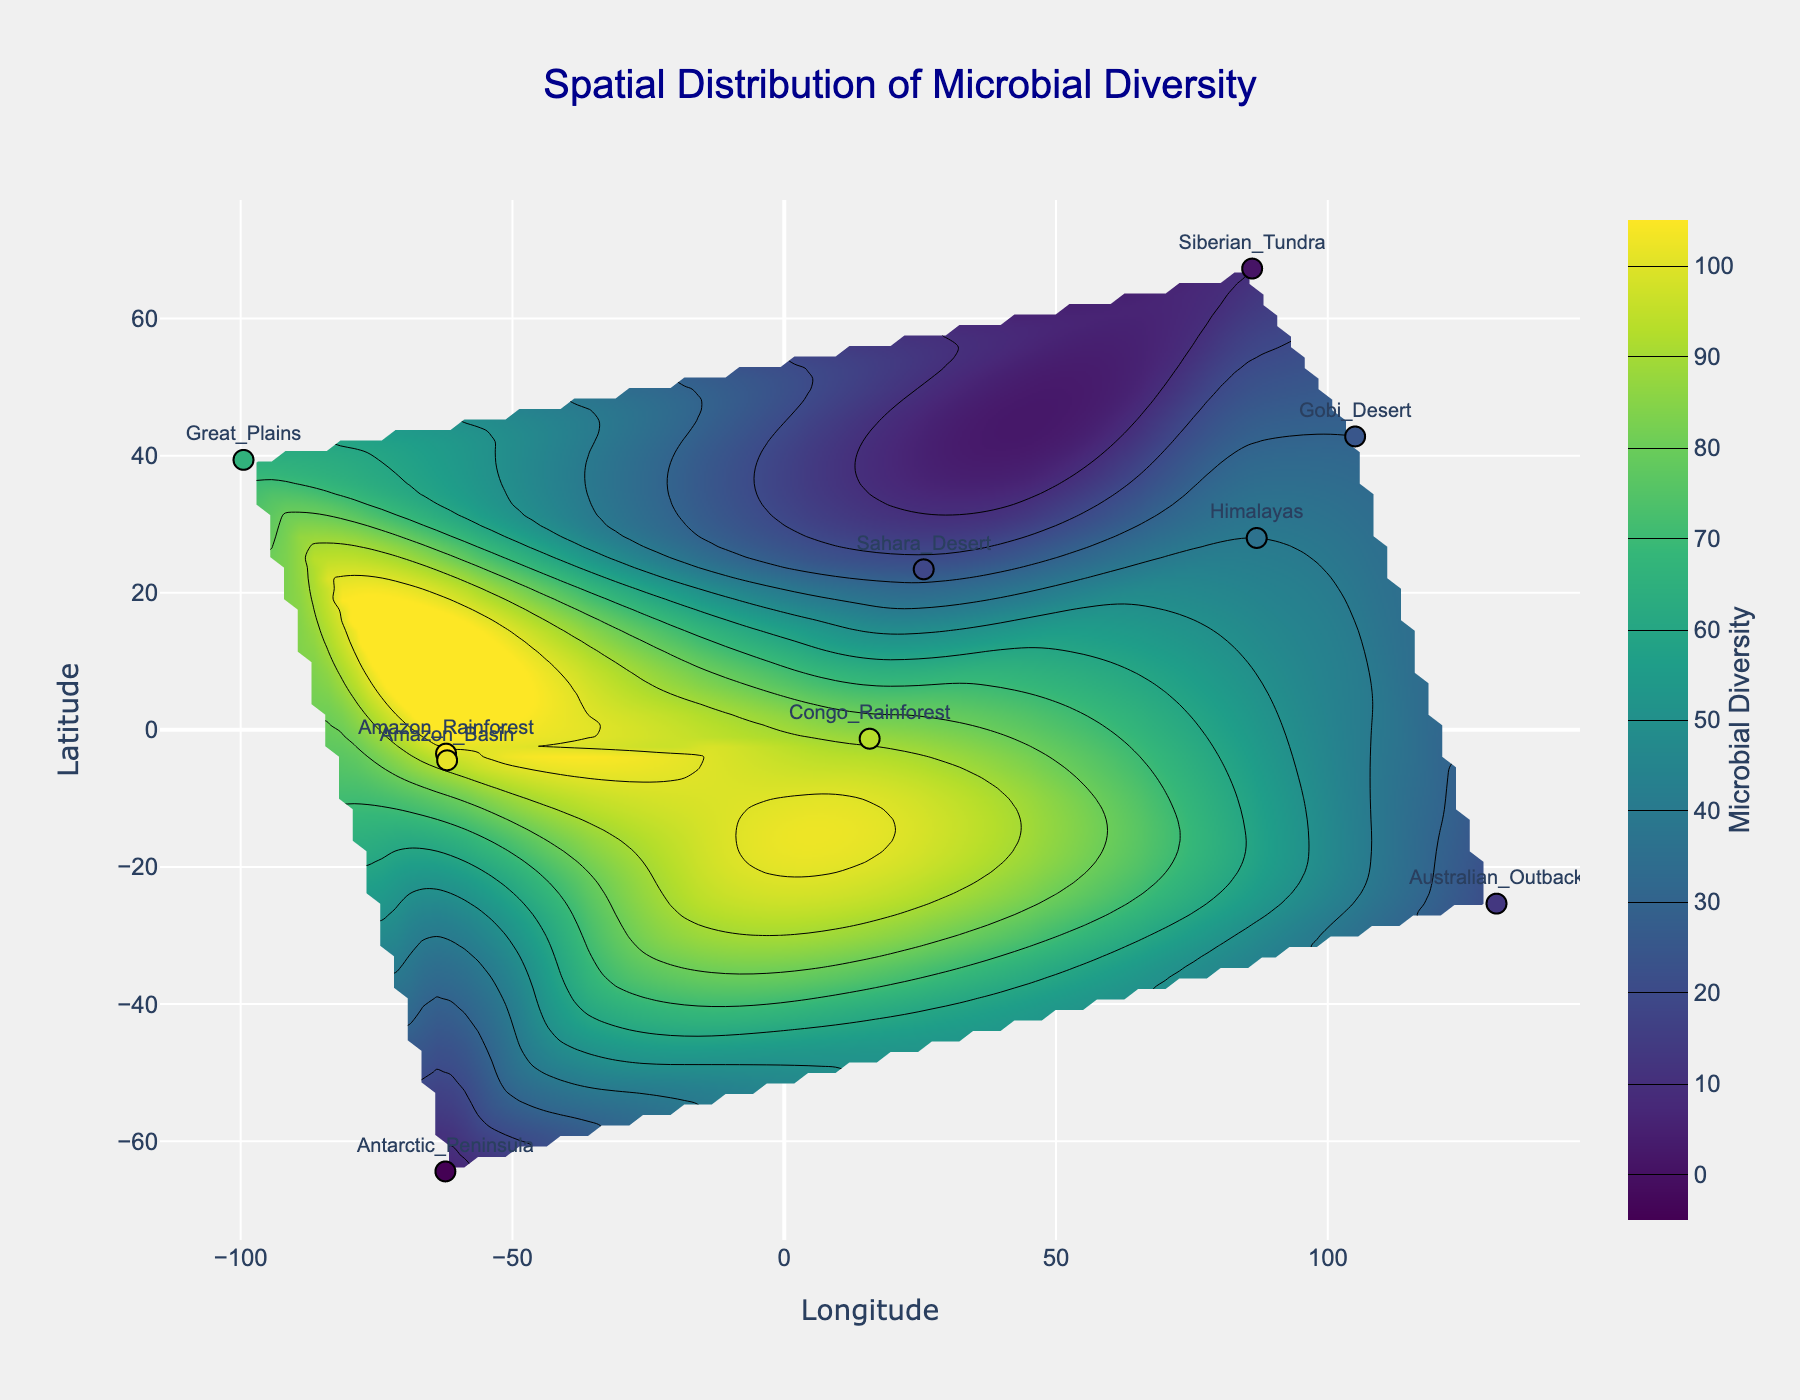How many locations are plotted on the figure? Count the number of discrete data points (locations) marked on the scatter plot overlay.
Answer: 10 Which location has the highest microbial diversity? Identify the point with the maximum value on the color scale, cross-referenced with the labeled location near that point.
Answer: Amazon Rainforest What is the title of the figure? Look at the title text at the top of the figure.
Answer: Spatial Distribution of Microbial Diversity Compare microbial diversity between the Amazon Rainforest and the Sahara Desert. Which one is higher? Check the microbial diversity values for both locations and compare them. Amazon Rainforest has a value of 98, while Sahara Desert has 25.
Answer: Amazon Rainforest What is the latitude and longitude range covered in the plot? Observe the x-axis (Longitude) and y-axis (Latitude) to determine the minimum and maximum values displayed.
Answer: -72.2159 to 115.0324 (Longitude), -74.4086 to 77.2868 (Latitude) Estimate the microbial diversity in the central Great Plains region based on the contour plot. Look at the contour lines and color gradient around the coordinates for the Great Plains.
Answer: Approximately 65 Describe the overall color gradient used for representing microbial diversity. Observe the color scale bar on the side and note the transition of colors from low to high values.
Answer: Ranges from dark blue (low) to yellow (high) Among the given locations, which one shows the lowest microbial diversity and what is its value? Identify the location with the least vibrant color on the contour plot and check its corresponding label and value. Antarctic Peninsula has a value of 5.
Answer: Antarctic Peninsula Compare the microbial diversity between the Great Plains and the Himalayan region. Which one has higher diversity? Check the microbial diversity values for both the Great Plains (65) and the Himalayas (40).
Answer: Great Plains What kind of visual representation is used to show microbial diversity across geographical locations? Identify the type of plot used, which includes contour lines and a color gradient.
Answer: 2D contour plot 